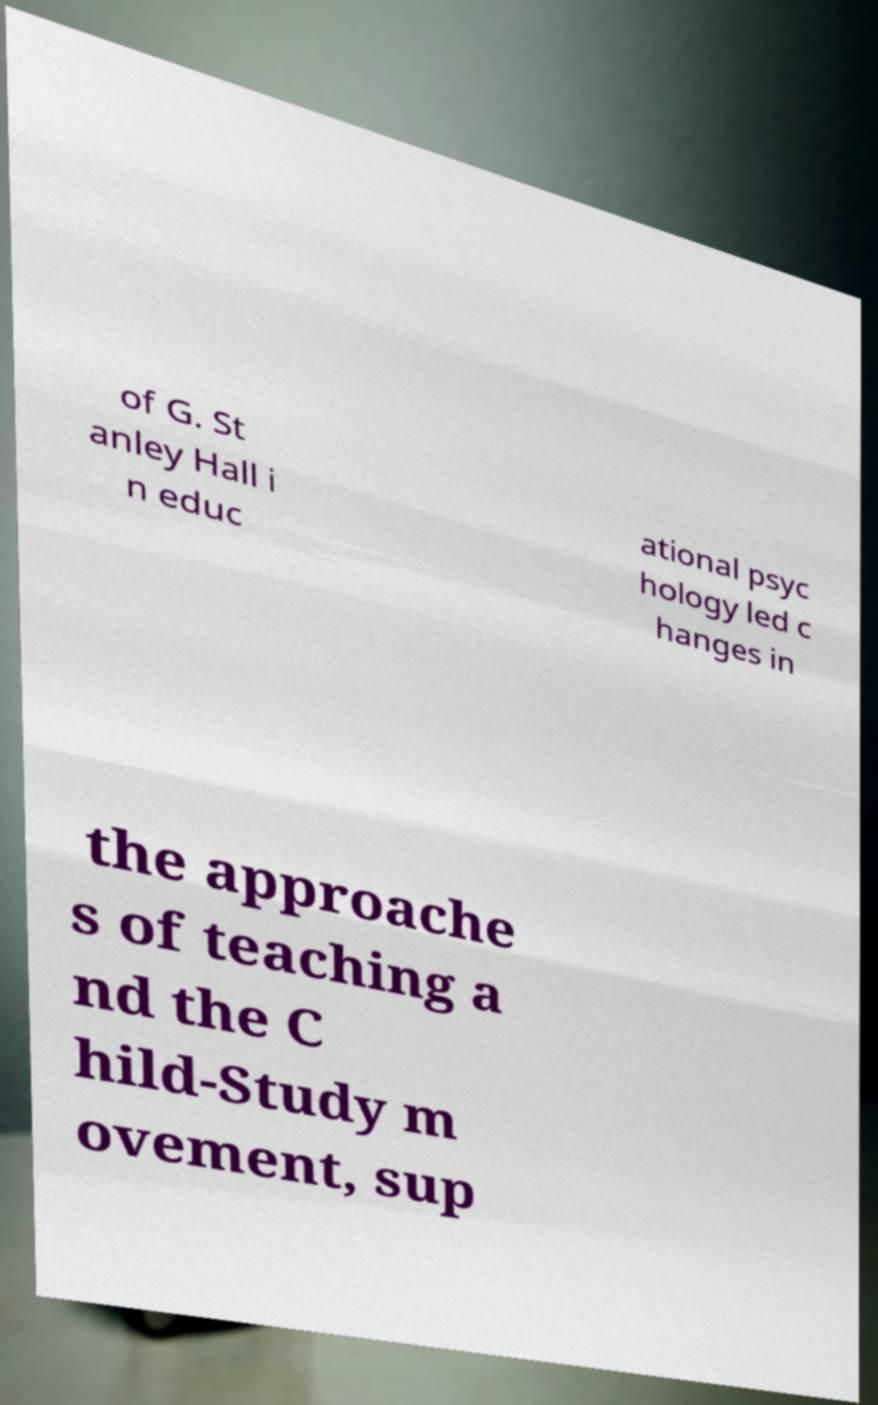For documentation purposes, I need the text within this image transcribed. Could you provide that? of G. St anley Hall i n educ ational psyc hology led c hanges in the approache s of teaching a nd the C hild-Study m ovement, sup 